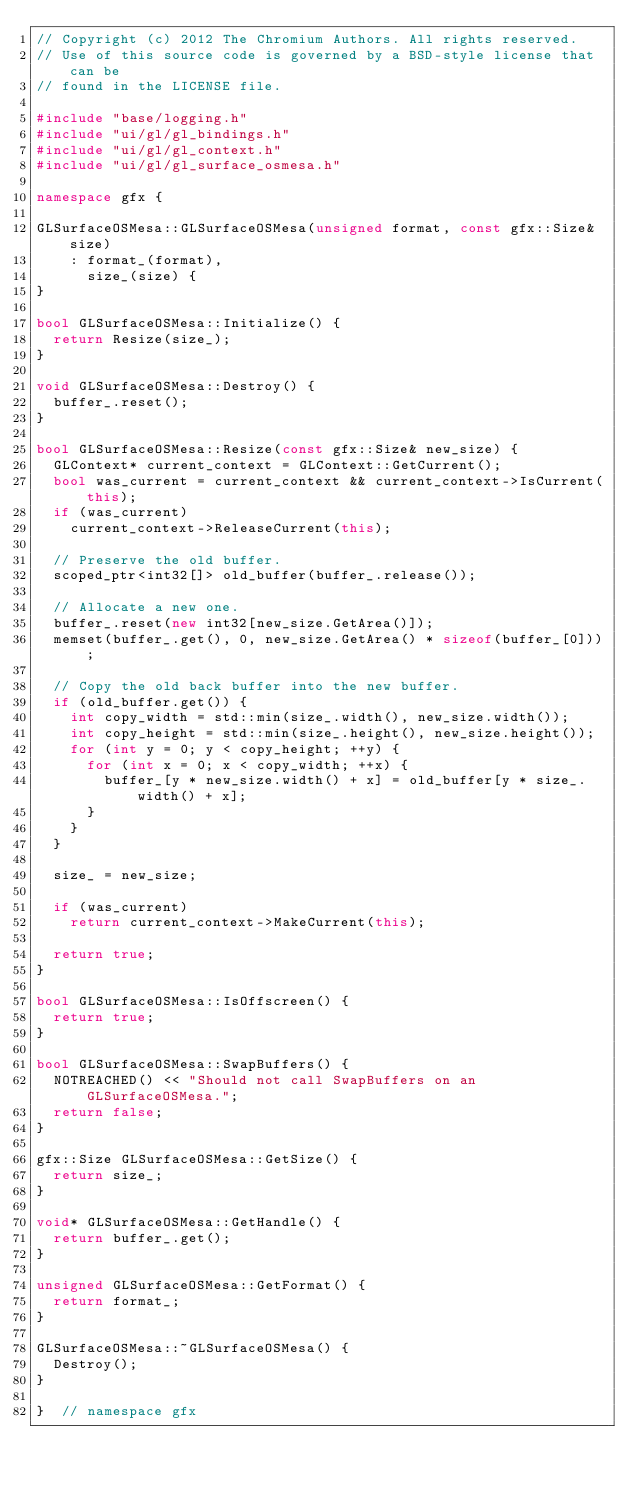<code> <loc_0><loc_0><loc_500><loc_500><_C++_>// Copyright (c) 2012 The Chromium Authors. All rights reserved.
// Use of this source code is governed by a BSD-style license that can be
// found in the LICENSE file.

#include "base/logging.h"
#include "ui/gl/gl_bindings.h"
#include "ui/gl/gl_context.h"
#include "ui/gl/gl_surface_osmesa.h"

namespace gfx {

GLSurfaceOSMesa::GLSurfaceOSMesa(unsigned format, const gfx::Size& size)
    : format_(format),
      size_(size) {
}

bool GLSurfaceOSMesa::Initialize() {
  return Resize(size_);
}

void GLSurfaceOSMesa::Destroy() {
  buffer_.reset();
}

bool GLSurfaceOSMesa::Resize(const gfx::Size& new_size) {
  GLContext* current_context = GLContext::GetCurrent();
  bool was_current = current_context && current_context->IsCurrent(this);
  if (was_current)
    current_context->ReleaseCurrent(this);

  // Preserve the old buffer.
  scoped_ptr<int32[]> old_buffer(buffer_.release());

  // Allocate a new one.
  buffer_.reset(new int32[new_size.GetArea()]);
  memset(buffer_.get(), 0, new_size.GetArea() * sizeof(buffer_[0]));

  // Copy the old back buffer into the new buffer.
  if (old_buffer.get()) {
    int copy_width = std::min(size_.width(), new_size.width());
    int copy_height = std::min(size_.height(), new_size.height());
    for (int y = 0; y < copy_height; ++y) {
      for (int x = 0; x < copy_width; ++x) {
        buffer_[y * new_size.width() + x] = old_buffer[y * size_.width() + x];
      }
    }
  }

  size_ = new_size;

  if (was_current)
    return current_context->MakeCurrent(this);

  return true;
}

bool GLSurfaceOSMesa::IsOffscreen() {
  return true;
}

bool GLSurfaceOSMesa::SwapBuffers() {
  NOTREACHED() << "Should not call SwapBuffers on an GLSurfaceOSMesa.";
  return false;
}

gfx::Size GLSurfaceOSMesa::GetSize() {
  return size_;
}

void* GLSurfaceOSMesa::GetHandle() {
  return buffer_.get();
}

unsigned GLSurfaceOSMesa::GetFormat() {
  return format_;
}

GLSurfaceOSMesa::~GLSurfaceOSMesa() {
  Destroy();
}

}  // namespace gfx
</code> 